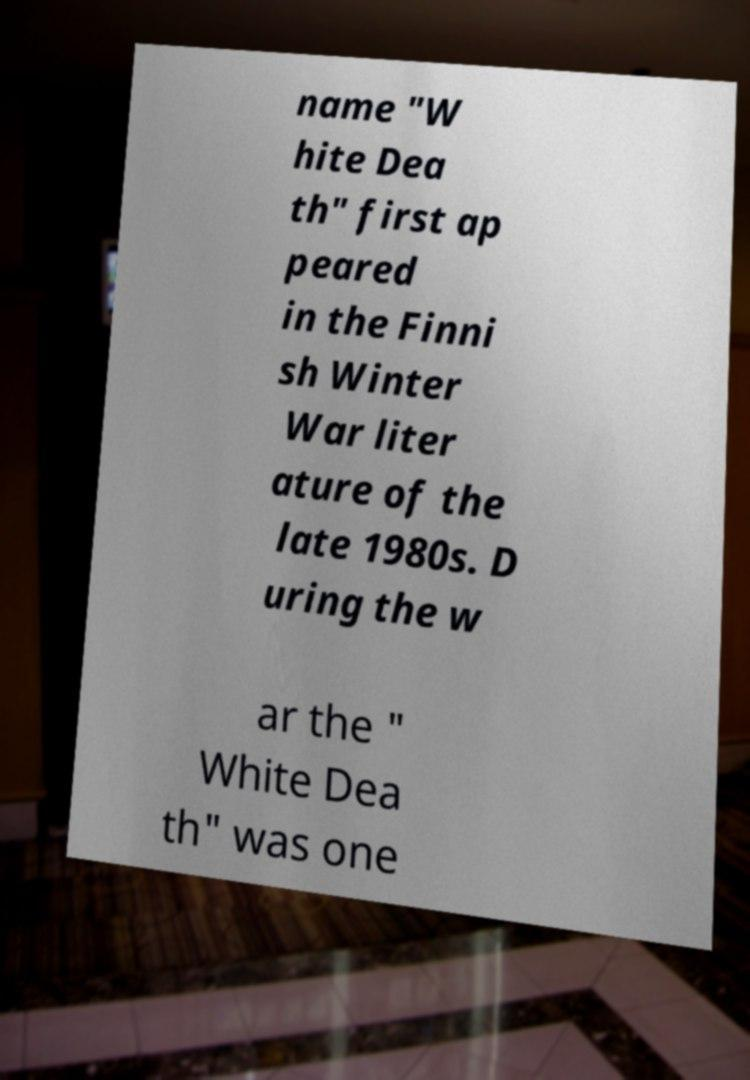I need the written content from this picture converted into text. Can you do that? name "W hite Dea th" first ap peared in the Finni sh Winter War liter ature of the late 1980s. D uring the w ar the " White Dea th" was one 